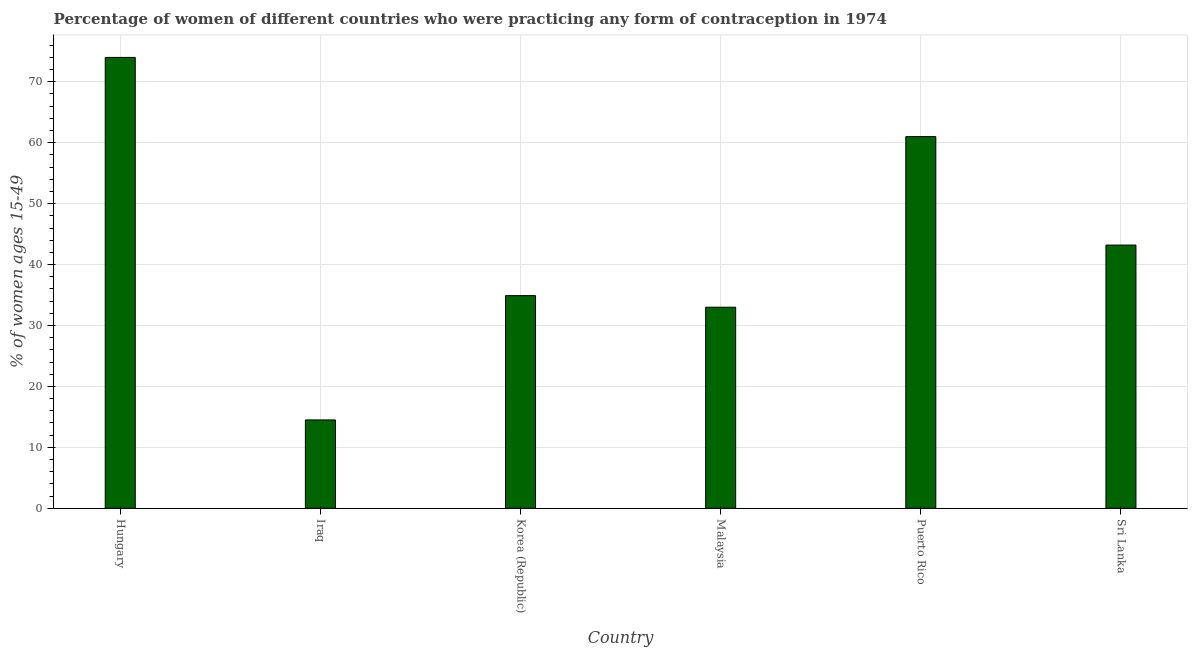Does the graph contain any zero values?
Ensure brevity in your answer.  No. What is the title of the graph?
Offer a terse response. Percentage of women of different countries who were practicing any form of contraception in 1974. What is the label or title of the X-axis?
Your answer should be very brief. Country. What is the label or title of the Y-axis?
Keep it short and to the point. % of women ages 15-49. What is the contraceptive prevalence in Korea (Republic)?
Give a very brief answer. 34.9. Across all countries, what is the minimum contraceptive prevalence?
Provide a succinct answer. 14.5. In which country was the contraceptive prevalence maximum?
Keep it short and to the point. Hungary. In which country was the contraceptive prevalence minimum?
Your answer should be compact. Iraq. What is the sum of the contraceptive prevalence?
Ensure brevity in your answer.  260.6. What is the difference between the contraceptive prevalence in Hungary and Iraq?
Make the answer very short. 59.5. What is the average contraceptive prevalence per country?
Provide a short and direct response. 43.43. What is the median contraceptive prevalence?
Offer a terse response. 39.05. What is the ratio of the contraceptive prevalence in Puerto Rico to that in Sri Lanka?
Your answer should be compact. 1.41. Is the difference between the contraceptive prevalence in Korea (Republic) and Puerto Rico greater than the difference between any two countries?
Offer a terse response. No. What is the difference between the highest and the lowest contraceptive prevalence?
Ensure brevity in your answer.  59.5. In how many countries, is the contraceptive prevalence greater than the average contraceptive prevalence taken over all countries?
Your answer should be compact. 2. How many bars are there?
Give a very brief answer. 6. Are all the bars in the graph horizontal?
Your response must be concise. No. Are the values on the major ticks of Y-axis written in scientific E-notation?
Your response must be concise. No. What is the % of women ages 15-49 in Korea (Republic)?
Offer a terse response. 34.9. What is the % of women ages 15-49 of Malaysia?
Your response must be concise. 33. What is the % of women ages 15-49 of Sri Lanka?
Offer a very short reply. 43.2. What is the difference between the % of women ages 15-49 in Hungary and Iraq?
Provide a succinct answer. 59.5. What is the difference between the % of women ages 15-49 in Hungary and Korea (Republic)?
Offer a very short reply. 39.1. What is the difference between the % of women ages 15-49 in Hungary and Malaysia?
Your answer should be compact. 41. What is the difference between the % of women ages 15-49 in Hungary and Sri Lanka?
Keep it short and to the point. 30.8. What is the difference between the % of women ages 15-49 in Iraq and Korea (Republic)?
Keep it short and to the point. -20.4. What is the difference between the % of women ages 15-49 in Iraq and Malaysia?
Your answer should be compact. -18.5. What is the difference between the % of women ages 15-49 in Iraq and Puerto Rico?
Offer a very short reply. -46.5. What is the difference between the % of women ages 15-49 in Iraq and Sri Lanka?
Your response must be concise. -28.7. What is the difference between the % of women ages 15-49 in Korea (Republic) and Puerto Rico?
Your answer should be compact. -26.1. What is the difference between the % of women ages 15-49 in Korea (Republic) and Sri Lanka?
Keep it short and to the point. -8.3. What is the difference between the % of women ages 15-49 in Malaysia and Sri Lanka?
Offer a terse response. -10.2. What is the difference between the % of women ages 15-49 in Puerto Rico and Sri Lanka?
Offer a terse response. 17.8. What is the ratio of the % of women ages 15-49 in Hungary to that in Iraq?
Your answer should be compact. 5.1. What is the ratio of the % of women ages 15-49 in Hungary to that in Korea (Republic)?
Provide a short and direct response. 2.12. What is the ratio of the % of women ages 15-49 in Hungary to that in Malaysia?
Your response must be concise. 2.24. What is the ratio of the % of women ages 15-49 in Hungary to that in Puerto Rico?
Keep it short and to the point. 1.21. What is the ratio of the % of women ages 15-49 in Hungary to that in Sri Lanka?
Provide a short and direct response. 1.71. What is the ratio of the % of women ages 15-49 in Iraq to that in Korea (Republic)?
Offer a very short reply. 0.41. What is the ratio of the % of women ages 15-49 in Iraq to that in Malaysia?
Offer a terse response. 0.44. What is the ratio of the % of women ages 15-49 in Iraq to that in Puerto Rico?
Your answer should be very brief. 0.24. What is the ratio of the % of women ages 15-49 in Iraq to that in Sri Lanka?
Offer a very short reply. 0.34. What is the ratio of the % of women ages 15-49 in Korea (Republic) to that in Malaysia?
Provide a short and direct response. 1.06. What is the ratio of the % of women ages 15-49 in Korea (Republic) to that in Puerto Rico?
Give a very brief answer. 0.57. What is the ratio of the % of women ages 15-49 in Korea (Republic) to that in Sri Lanka?
Your response must be concise. 0.81. What is the ratio of the % of women ages 15-49 in Malaysia to that in Puerto Rico?
Offer a very short reply. 0.54. What is the ratio of the % of women ages 15-49 in Malaysia to that in Sri Lanka?
Provide a succinct answer. 0.76. What is the ratio of the % of women ages 15-49 in Puerto Rico to that in Sri Lanka?
Give a very brief answer. 1.41. 